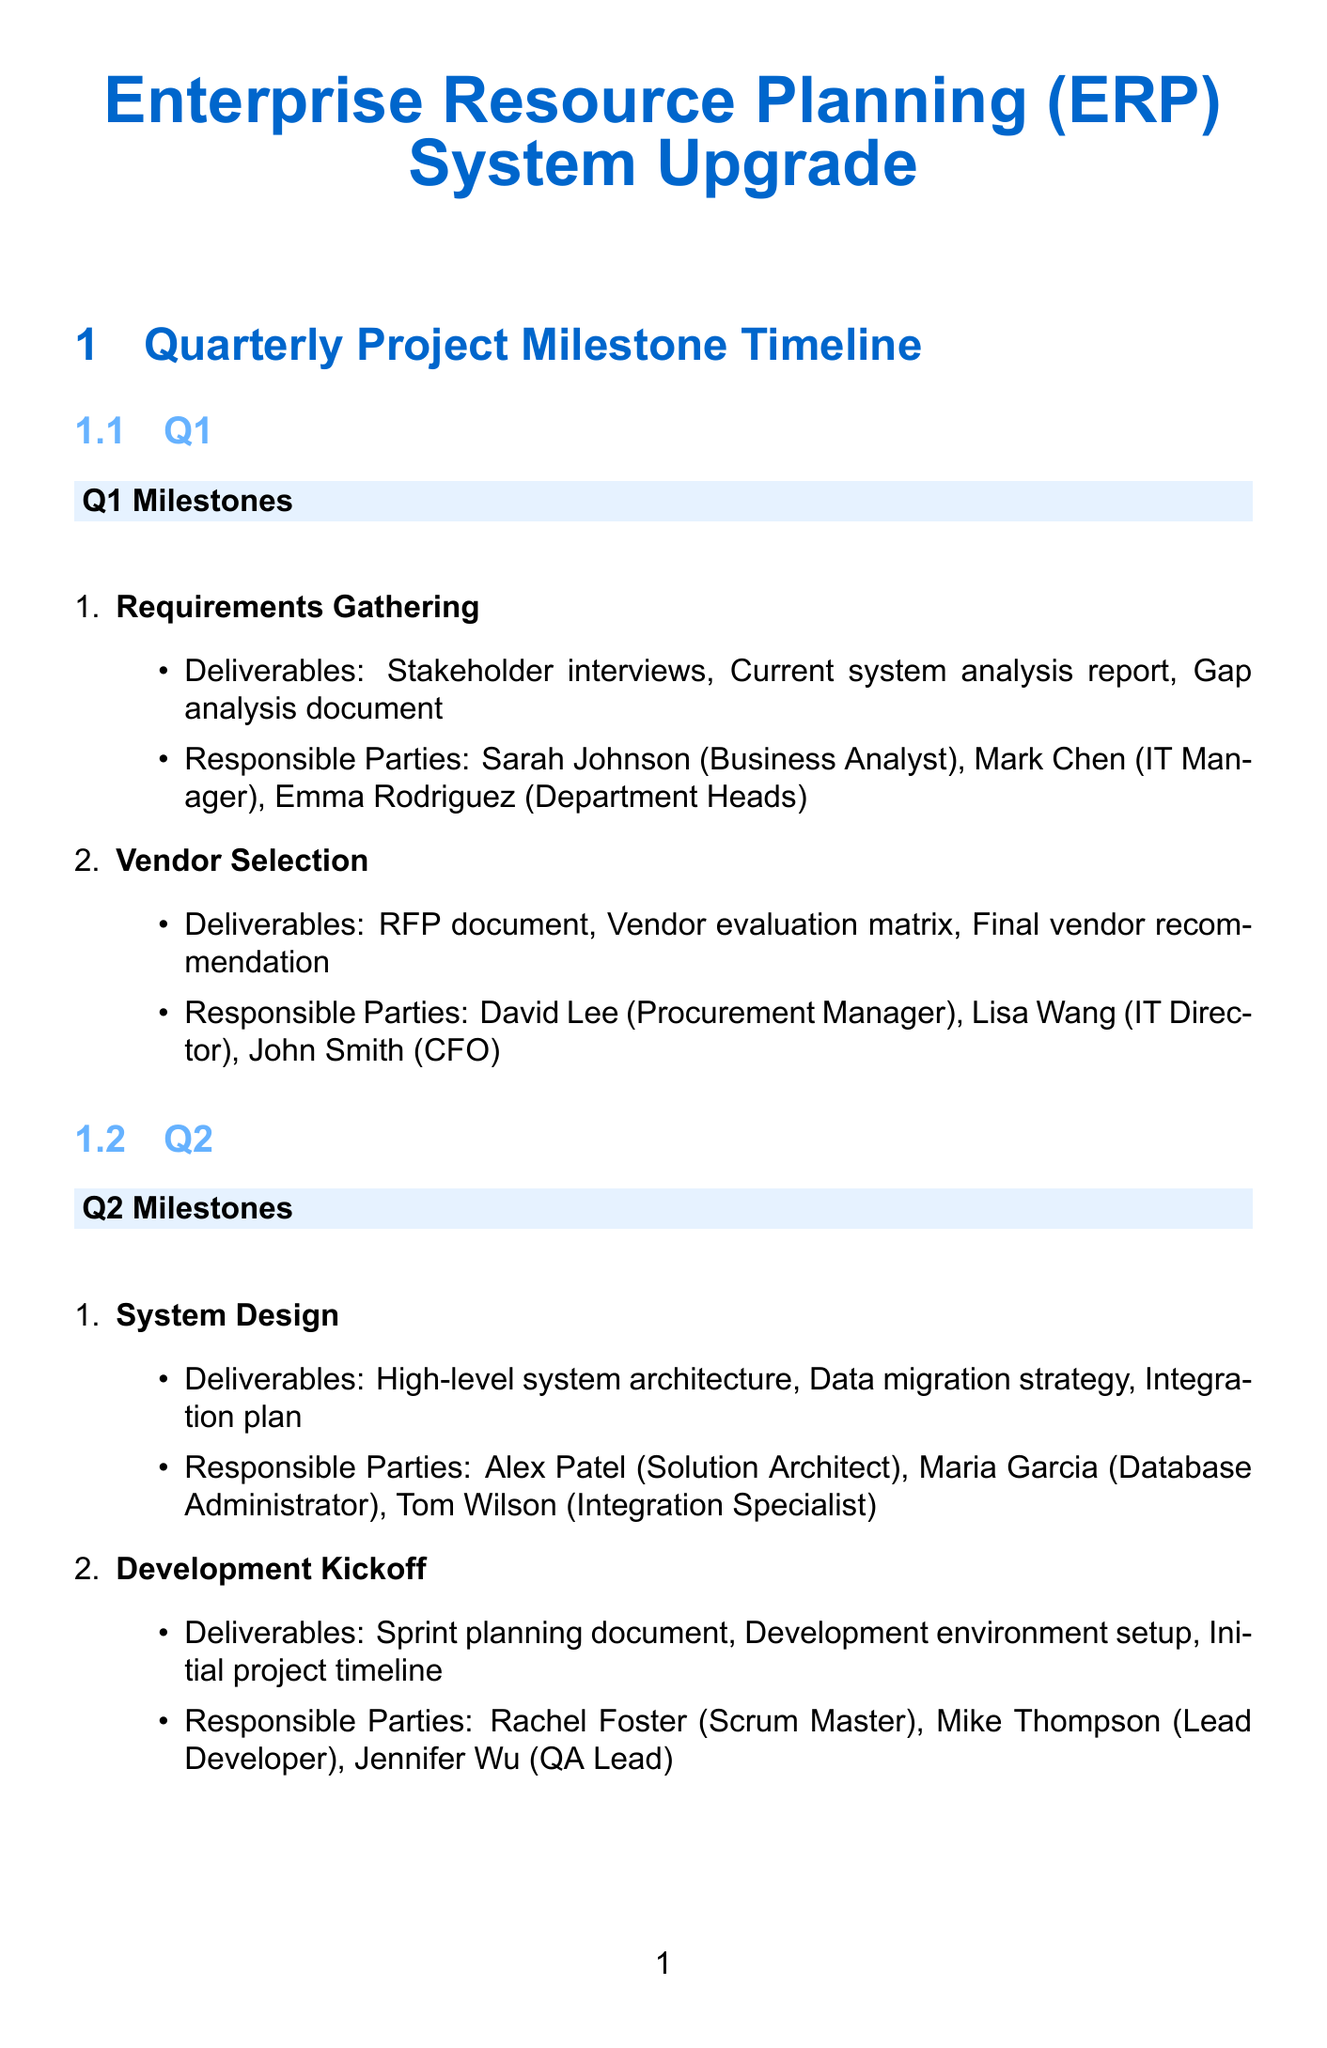what are the deliverables for the Requirements Gathering milestone? The deliverables listed for the Requirements Gathering milestone are stakeholder interviews, current system analysis report, and gap analysis document.
Answer: stakeholder interviews, current system analysis report, gap analysis document who is responsible for the User Acceptance Testing (UAT)? The responsible parties for the User Acceptance Testing (UAT) are Jennifer Wu, Emma Rodriguez, and Sarah Johnson.
Answer: Jennifer Wu, Emma Rodriguez, Sarah Johnson how many milestones are in Q4? The milestones in Q4 are Data Migration, Go-Live Preparation, and System Launch, totaling three.
Answer: three which quarter includes the Development Kickoff milestone? The Development Kickoff milestone is part of Q2.
Answer: Q2 what is the last deliverable listed for the System Launch milestone? The last deliverable for the System Launch milestone is the project closure report.
Answer: project closure report who is the Solution Architect responsible for the System Design? Alex Patel is the Solution Architect responsible for the System Design milestone.
Answer: Alex Patel which milestone has the deliverable labeled as Validation results? The deliverable labeled as Validation results belongs to the Data Migration milestone.
Answer: Data Migration in which quarter is the Core Module Development scheduled? The Core Module Development milestone is scheduled for Q3.
Answer: Q3 what document is produced during the Vendor Selection milestone? The produced document in the Vendor Selection milestone is the RFP document.
Answer: RFP document 